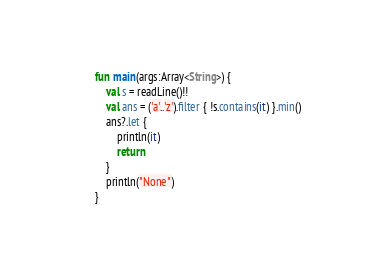Convert code to text. <code><loc_0><loc_0><loc_500><loc_500><_Kotlin_>fun main(args:Array<String>) {
    val s = readLine()!!
    val ans = ('a'..'z').filter { !s.contains(it) }.min()
    ans?.let {
        println(it)
        return
    }
    println("None")
}</code> 